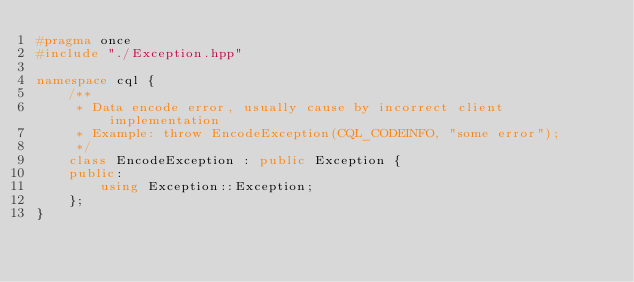Convert code to text. <code><loc_0><loc_0><loc_500><loc_500><_C++_>#pragma once
#include "./Exception.hpp"

namespace cql {
	/**
	 * Data encode error, usually cause by incorrect client implementation
	 * Example: throw EncodeException(CQL_CODEINFO, "some error");
	 */
	class EncodeException : public Exception {
	public:
		using Exception::Exception;
	};
}

</code> 